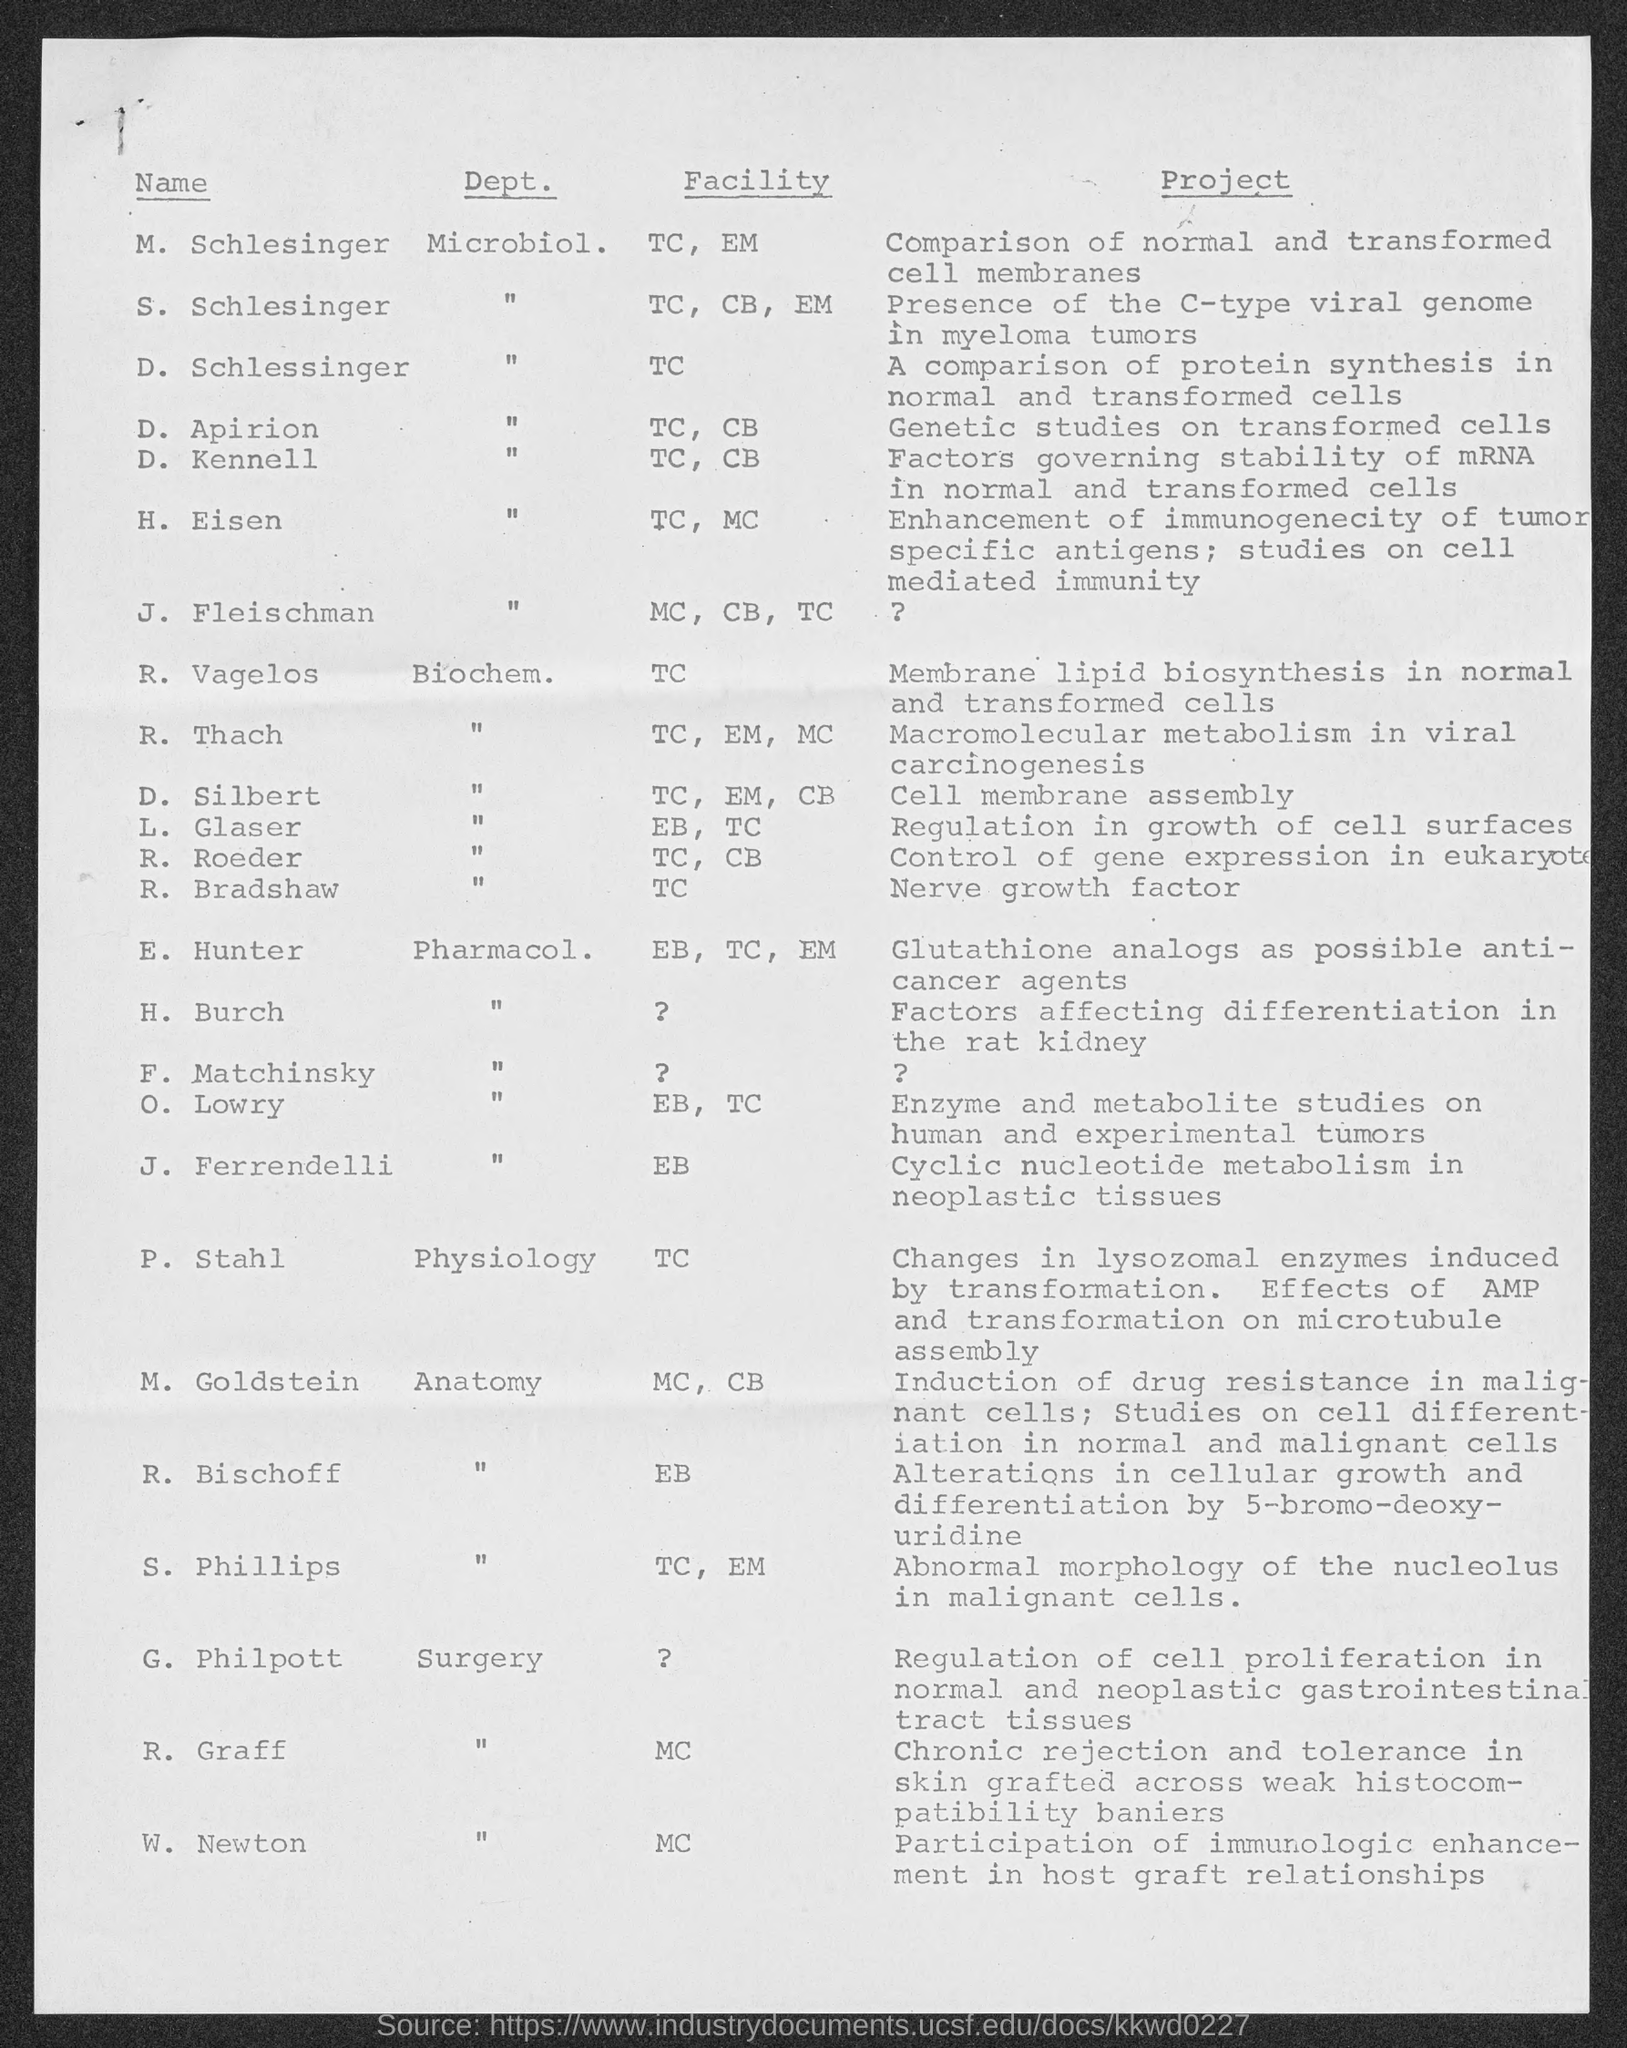Which dept. is M. Schlesinger part of?
Ensure brevity in your answer.  Microbiol. Which facility is H. Eisen part of?
Ensure brevity in your answer.  TC, MC. What is the project of D. Apirion?
Make the answer very short. Genetic studies on transformed cells. Who is heading Macromolecular metabolism in viral carcinogenesis?
Offer a very short reply. R. Thach. What is the project of J. Ferrendelli?
Ensure brevity in your answer.  Cyclic nucleotide metabolism in neoplastic tissues. 